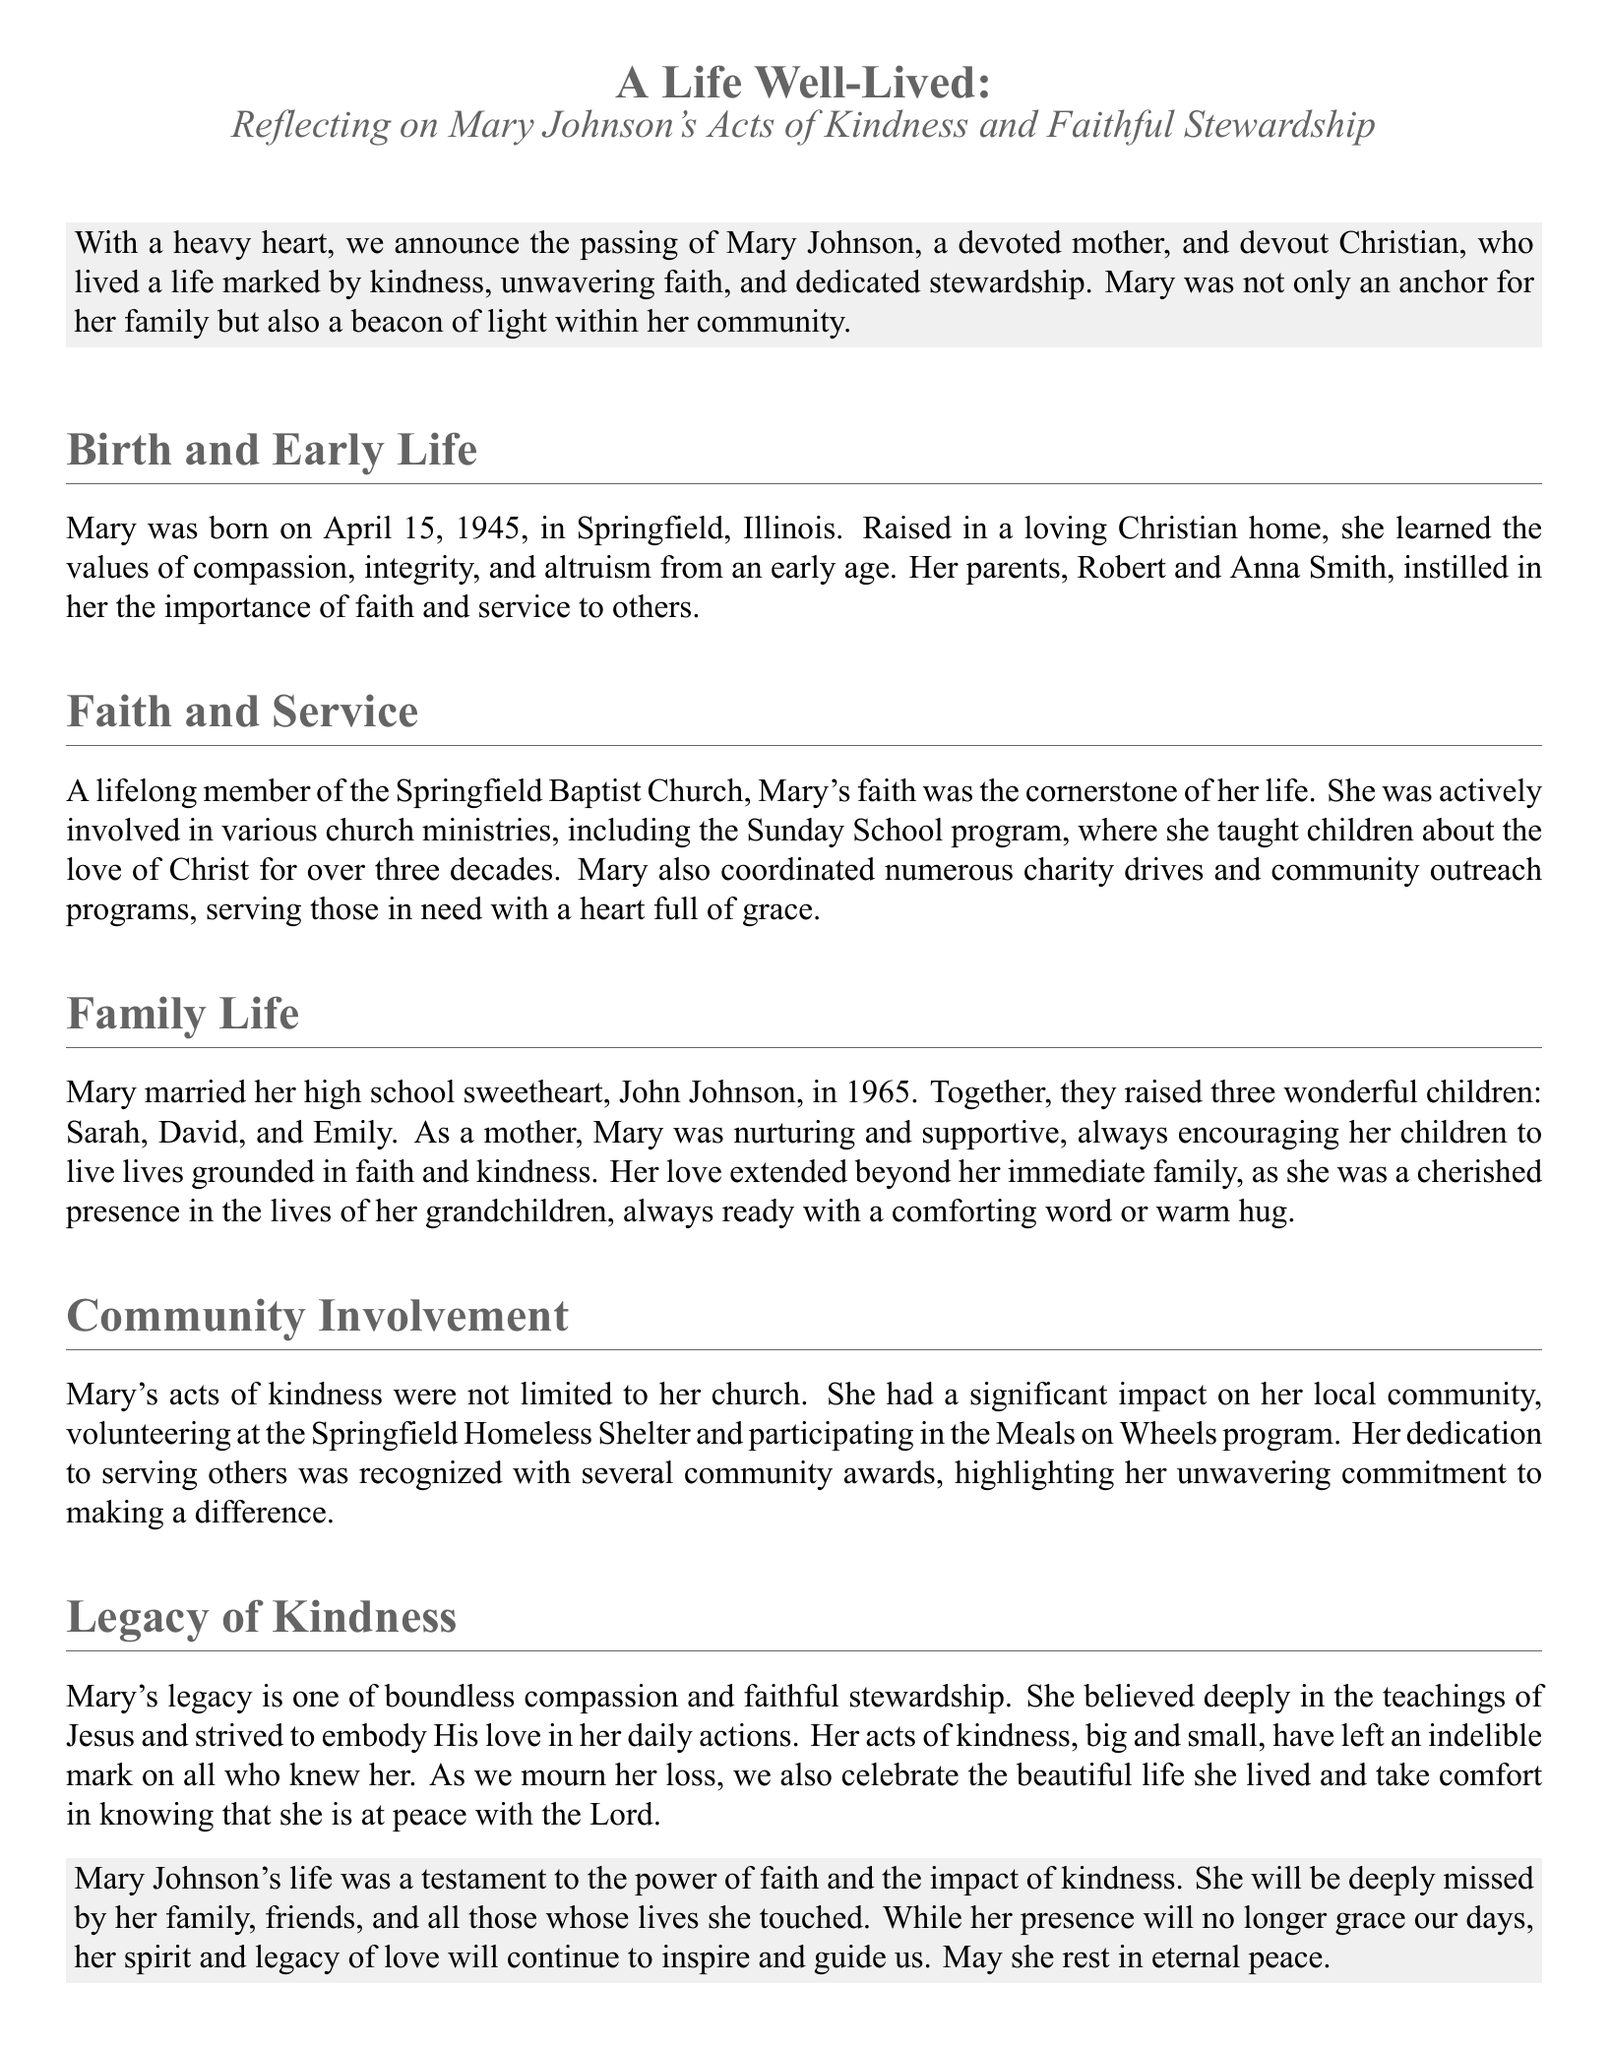what is the name of the deceased? The obituary specifically names the individual who has passed away as Mary Johnson.
Answer: Mary Johnson when was Mary Johnson born? The document provides the birth date of Mary Johnson as April 15, 1945.
Answer: April 15, 1945 what was one of Mary’s community activities? The document mentions her involvement in the Springfield Homeless Shelter as a significant community activity.
Answer: Springfield Homeless Shelter how many children did Mary Johnson have? The obituary states that Mary Johnson raised three children.
Answer: three what was the cornerstone of Mary’s life? The document indicates that Mary's faith was the cornerstone of her life.
Answer: faith who was Mary Johnson's husband? The obituary mentions that her husband was John Johnson.
Answer: John Johnson what role did Mary play in her church’s Sunday School program? The document explains that Mary taught children in the Sunday School program for over three decades.
Answer: taught children what is described as Mary’s legacy? The obituary states that Mary's legacy is one of boundless compassion and faithful stewardship.
Answer: boundless compassion and faithful stewardship what is the tone of the closing remarks in the obituary? The document indicates that the closing remarks convey a sense of peace and loss while celebrating her life.
Answer: peace and loss 